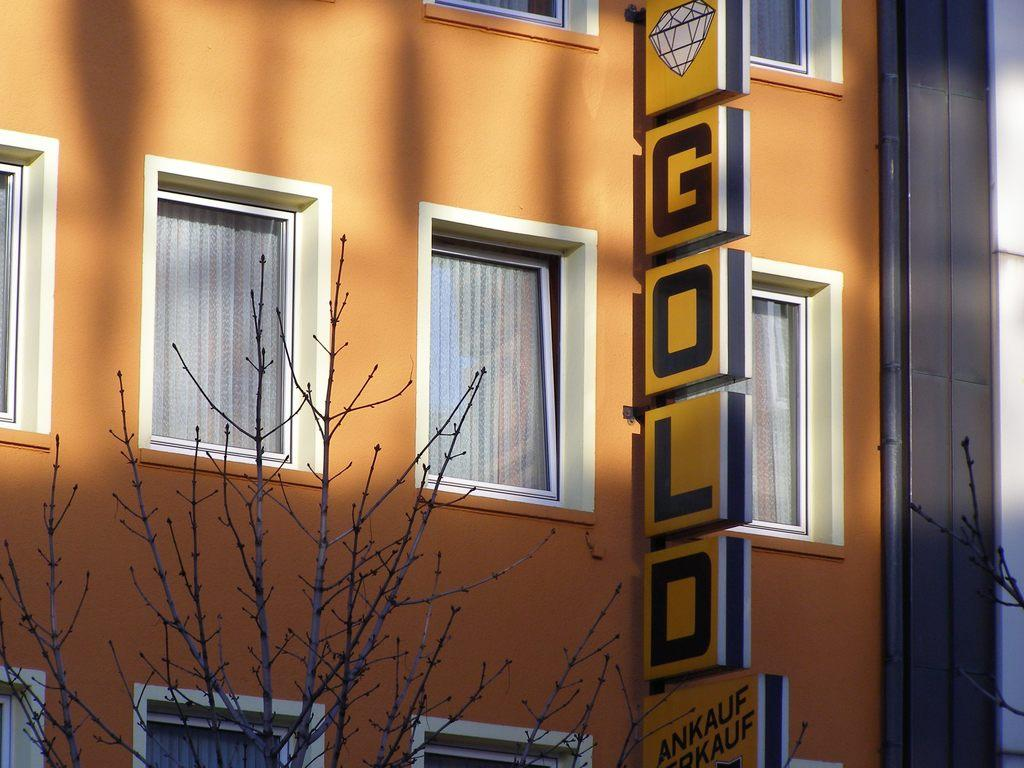What objects can be seen in the image? There are boards, a pipe, a building, windows, curtains, and branches in the image. What is the purpose of the boards in the image? Something is written on the boards, which suggests they might be used for communication or displaying information. What part of the building can be seen in the image? The windows and curtains are part of the building visible in the image. What is the condition of the branches in the image? The branches are visible in the image, but their condition cannot be determined without more information. Where is the market located in the image? There is no market present in the image. What type of pump is connected to the pipe in the image? There is no pump connected to the pipe in the image. 